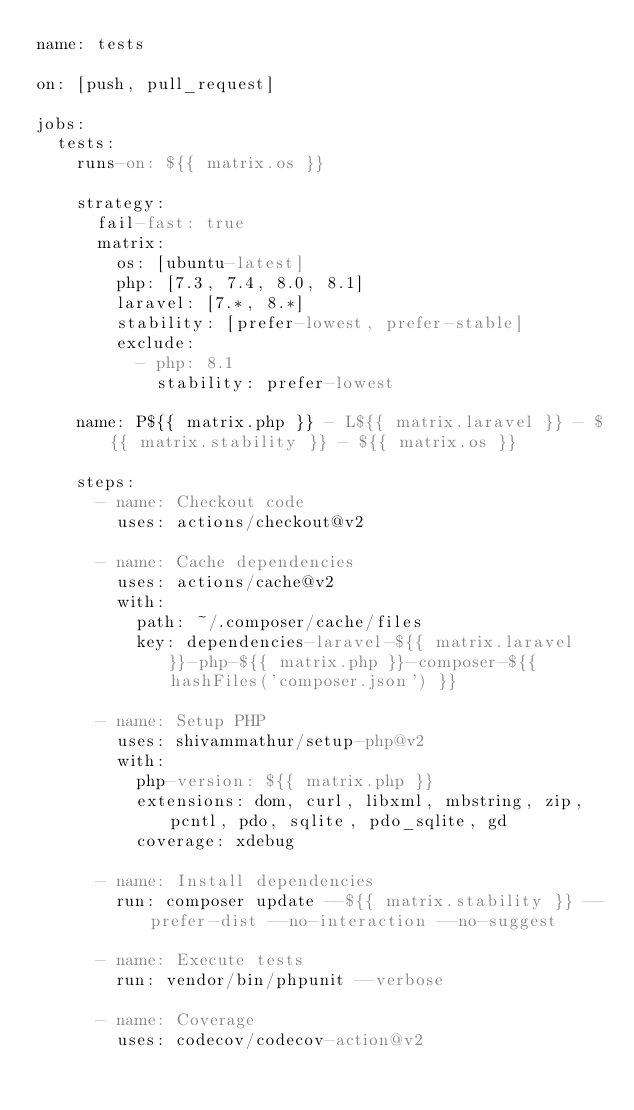<code> <loc_0><loc_0><loc_500><loc_500><_YAML_>name: tests

on: [push, pull_request]

jobs:
  tests:
    runs-on: ${{ matrix.os }}

    strategy:
      fail-fast: true
      matrix:
        os: [ubuntu-latest]
        php: [7.3, 7.4, 8.0, 8.1]
        laravel: [7.*, 8.*]
        stability: [prefer-lowest, prefer-stable]
        exclude:
          - php: 8.1
            stability: prefer-lowest

    name: P${{ matrix.php }} - L${{ matrix.laravel }} - ${{ matrix.stability }} - ${{ matrix.os }}

    steps:
      - name: Checkout code
        uses: actions/checkout@v2

      - name: Cache dependencies
        uses: actions/cache@v2
        with:
          path: ~/.composer/cache/files
          key: dependencies-laravel-${{ matrix.laravel }}-php-${{ matrix.php }}-composer-${{ hashFiles('composer.json') }}

      - name: Setup PHP
        uses: shivammathur/setup-php@v2
        with:
          php-version: ${{ matrix.php }}
          extensions: dom, curl, libxml, mbstring, zip, pcntl, pdo, sqlite, pdo_sqlite, gd
          coverage: xdebug

      - name: Install dependencies
        run: composer update --${{ matrix.stability }} --prefer-dist --no-interaction --no-suggest

      - name: Execute tests
        run: vendor/bin/phpunit --verbose

      - name: Coverage
        uses: codecov/codecov-action@v2
</code> 